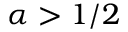<formula> <loc_0><loc_0><loc_500><loc_500>\alpha > 1 / 2</formula> 